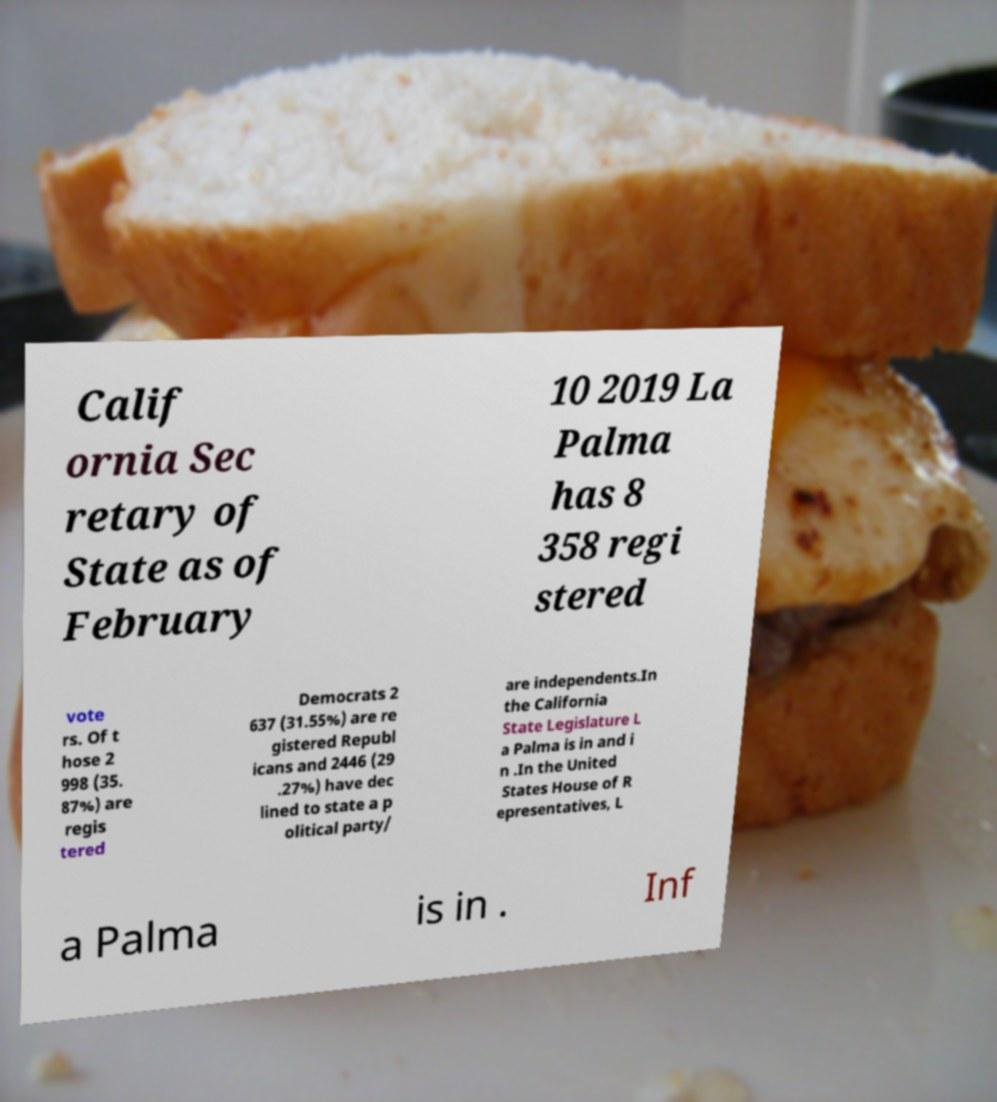Could you assist in decoding the text presented in this image and type it out clearly? Calif ornia Sec retary of State as of February 10 2019 La Palma has 8 358 regi stered vote rs. Of t hose 2 998 (35. 87%) are regis tered Democrats 2 637 (31.55%) are re gistered Republ icans and 2446 (29 .27%) have dec lined to state a p olitical party/ are independents.In the California State Legislature L a Palma is in and i n .In the United States House of R epresentatives, L a Palma is in . Inf 